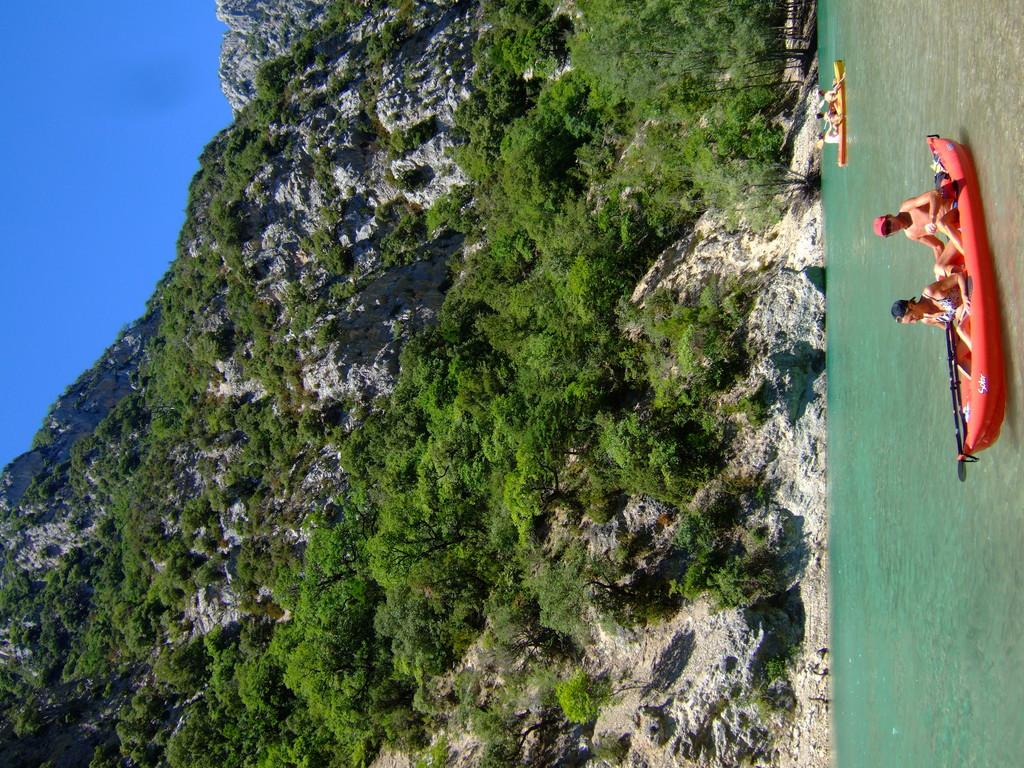What is the main subject of the image? The main subject of the image is water. What are the people in the image doing? People are travelling in boats on the water. What can be seen in the background of the image? There are mountains and plants/trees in the background of the image. What is visible at the top of the image? The sky is visible at the top of the image. What type of print can be seen on the sneeze in the image? There is no sneeze present in the image, and therefore no print can be observed. 